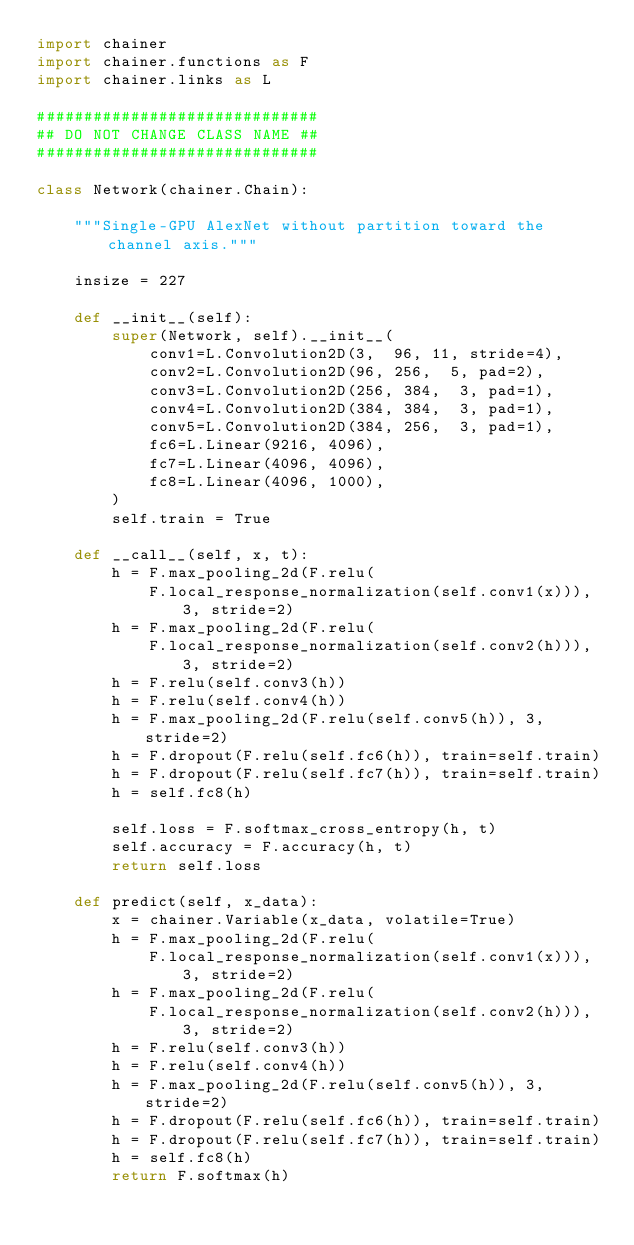<code> <loc_0><loc_0><loc_500><loc_500><_Python_>import chainer
import chainer.functions as F
import chainer.links as L

##############################
## DO NOT CHANGE CLASS NAME ##
##############################

class Network(chainer.Chain):

    """Single-GPU AlexNet without partition toward the channel axis."""

    insize = 227

    def __init__(self):
        super(Network, self).__init__(
            conv1=L.Convolution2D(3,  96, 11, stride=4),
            conv2=L.Convolution2D(96, 256,  5, pad=2),
            conv3=L.Convolution2D(256, 384,  3, pad=1),
            conv4=L.Convolution2D(384, 384,  3, pad=1),
            conv5=L.Convolution2D(384, 256,  3, pad=1),
            fc6=L.Linear(9216, 4096),
            fc7=L.Linear(4096, 4096),
            fc8=L.Linear(4096, 1000),
        )
        self.train = True

    def __call__(self, x, t):
        h = F.max_pooling_2d(F.relu(
            F.local_response_normalization(self.conv1(x))), 3, stride=2)
        h = F.max_pooling_2d(F.relu(
            F.local_response_normalization(self.conv2(h))), 3, stride=2)
        h = F.relu(self.conv3(h))
        h = F.relu(self.conv4(h))
        h = F.max_pooling_2d(F.relu(self.conv5(h)), 3, stride=2)
        h = F.dropout(F.relu(self.fc6(h)), train=self.train)
        h = F.dropout(F.relu(self.fc7(h)), train=self.train)
        h = self.fc8(h)

        self.loss = F.softmax_cross_entropy(h, t)
        self.accuracy = F.accuracy(h, t)
        return self.loss

    def predict(self, x_data):
        x = chainer.Variable(x_data, volatile=True)
        h = F.max_pooling_2d(F.relu(
            F.local_response_normalization(self.conv1(x))), 3, stride=2)
        h = F.max_pooling_2d(F.relu(
            F.local_response_normalization(self.conv2(h))), 3, stride=2)
        h = F.relu(self.conv3(h))
        h = F.relu(self.conv4(h))
        h = F.max_pooling_2d(F.relu(self.conv5(h)), 3, stride=2)
        h = F.dropout(F.relu(self.fc6(h)), train=self.train)
        h = F.dropout(F.relu(self.fc7(h)), train=self.train)
        h = self.fc8(h)
        return F.softmax(h)
</code> 